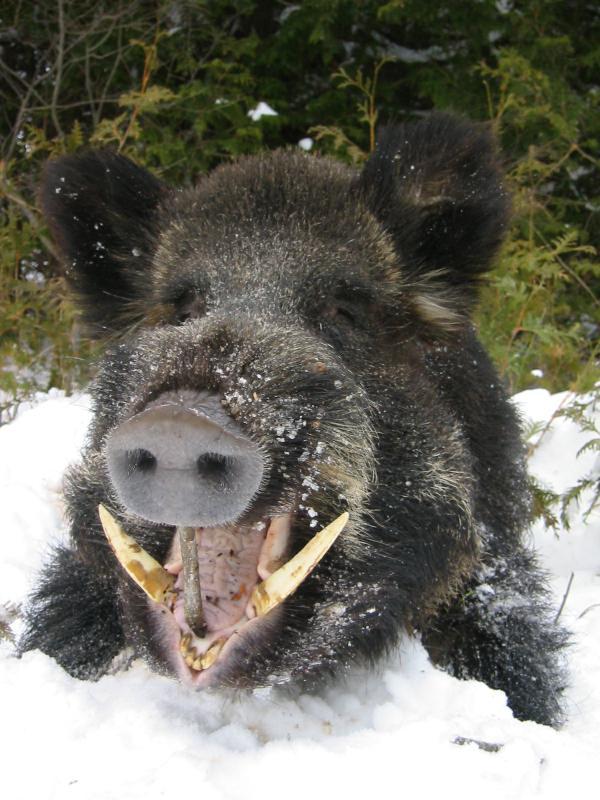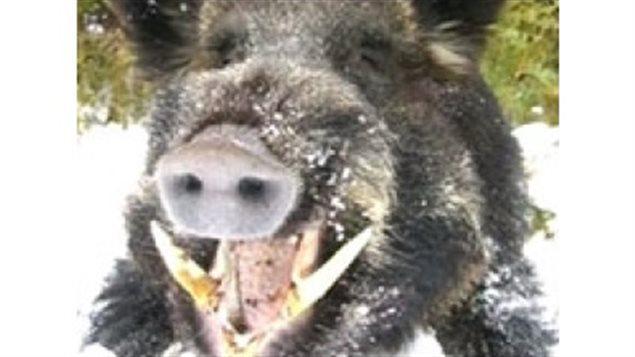The first image is the image on the left, the second image is the image on the right. Examine the images to the left and right. Is the description "There are at most two wild boars" accurate? Answer yes or no. Yes. The first image is the image on the left, the second image is the image on the right. Evaluate the accuracy of this statement regarding the images: "There are exactly two boars, and they don't look like the same boar.". Is it true? Answer yes or no. No. 